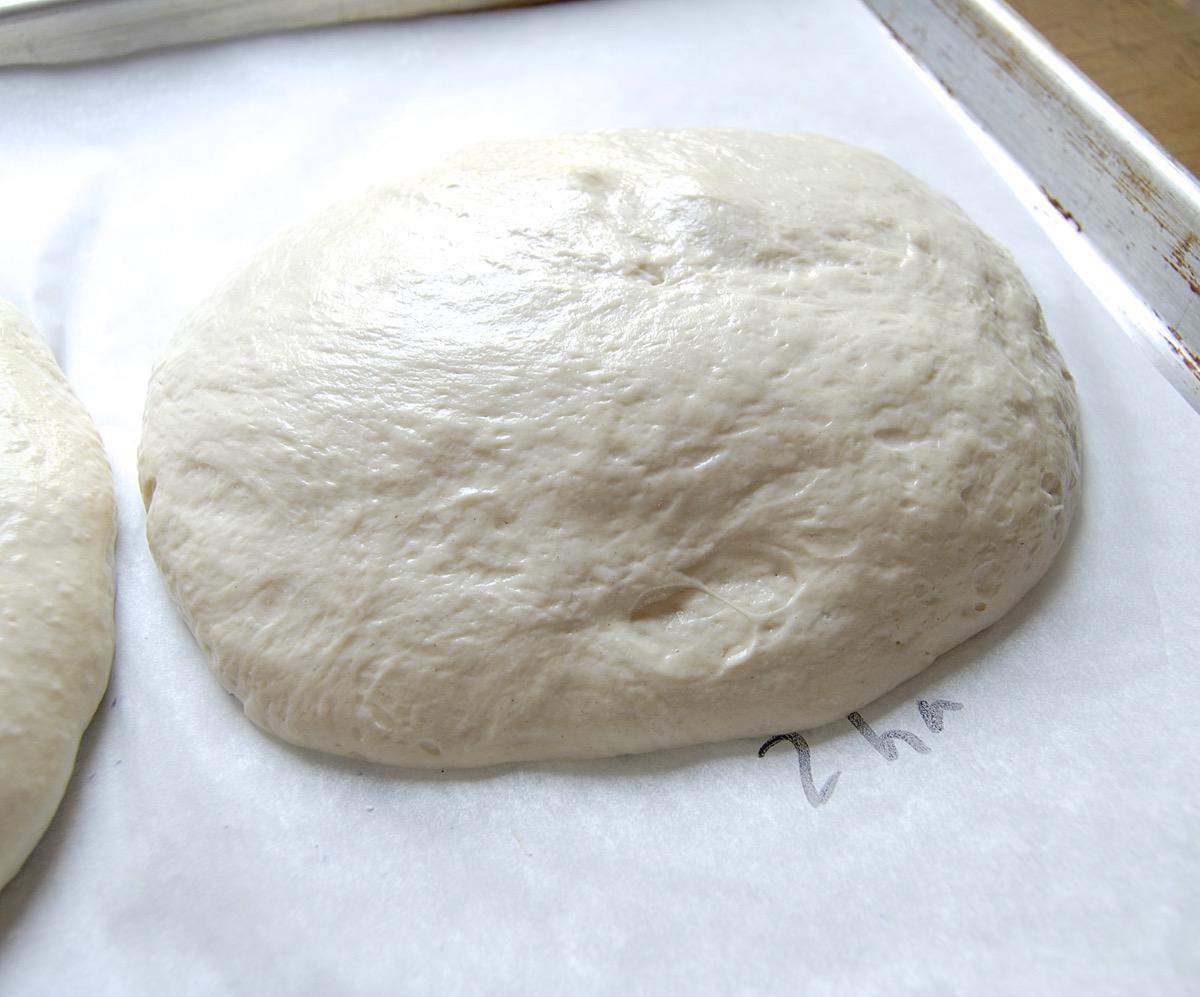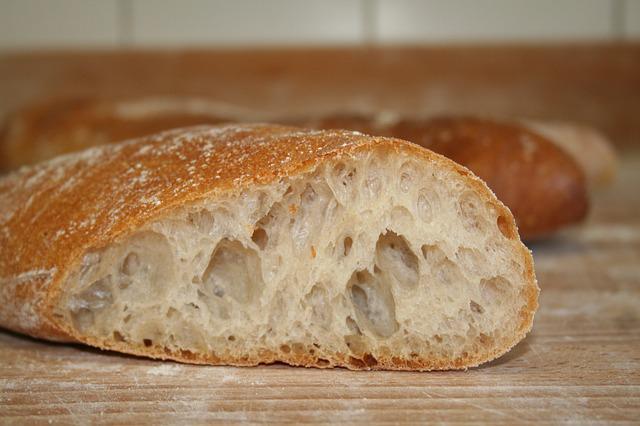The first image is the image on the left, the second image is the image on the right. For the images displayed, is the sentence "At least 2 globs of dough have been baked into crusty bread." factually correct? Answer yes or no. Yes. The first image is the image on the left, the second image is the image on the right. Examine the images to the left and right. Is the description "Each image contains exactly one rounded pale-colored raw dough ball, and one of the images features a dough ball on a wood surface dusted with flour." accurate? Answer yes or no. No. 